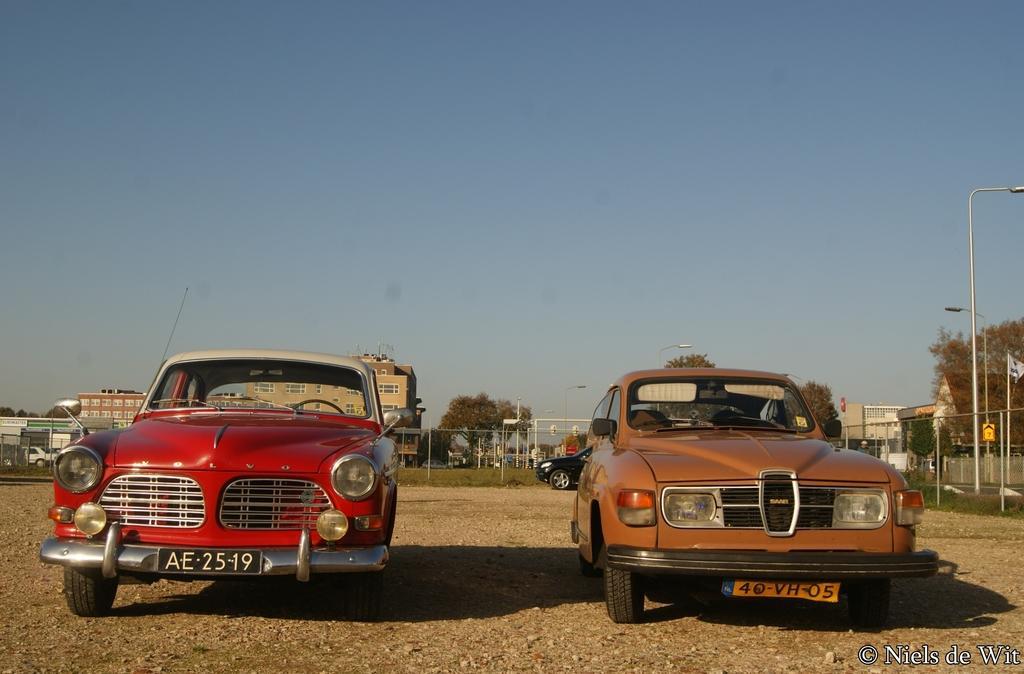How would you summarize this image in a sentence or two? In this picture we can see vehicles on the ground and in the background we can see buildings, trees, electric poles with lights, sky and some objects, in the bottom right we can see some text on it. 